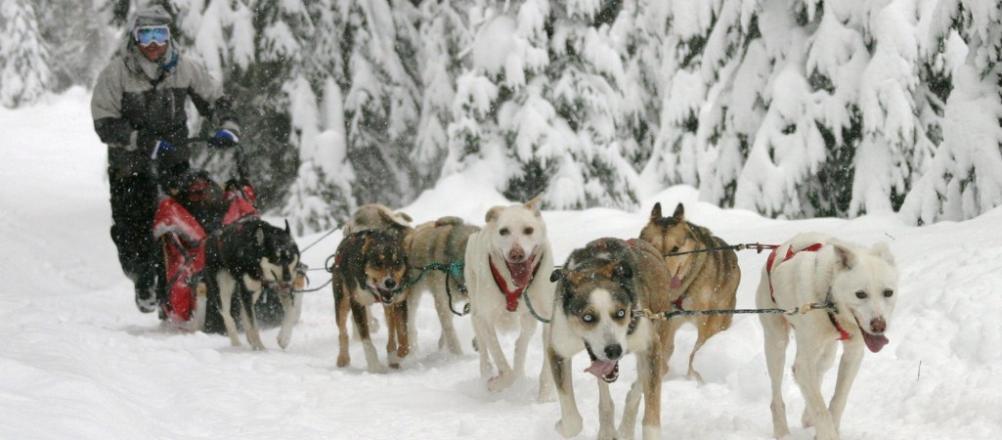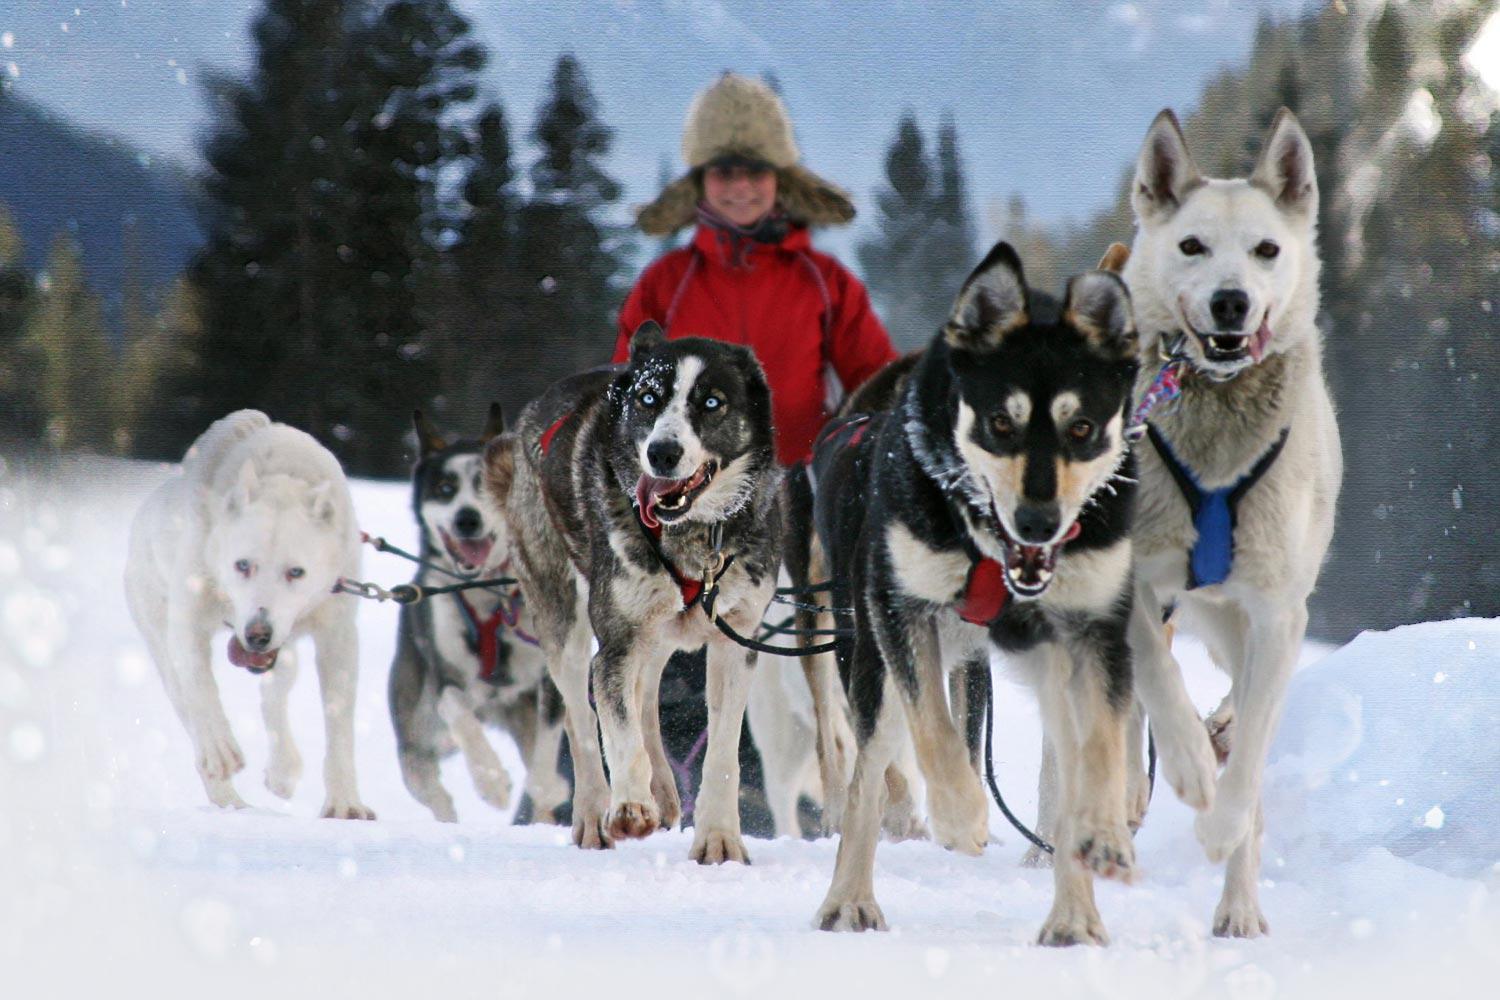The first image is the image on the left, the second image is the image on the right. Given the left and right images, does the statement "The righthand dog sled team heads straight toward the camera, and the lefthand team heads at a diagonal to the right." hold true? Answer yes or no. Yes. The first image is the image on the left, the second image is the image on the right. For the images displayed, is the sentence "The left image contains no more than six sled dogs." factually correct? Answer yes or no. No. 